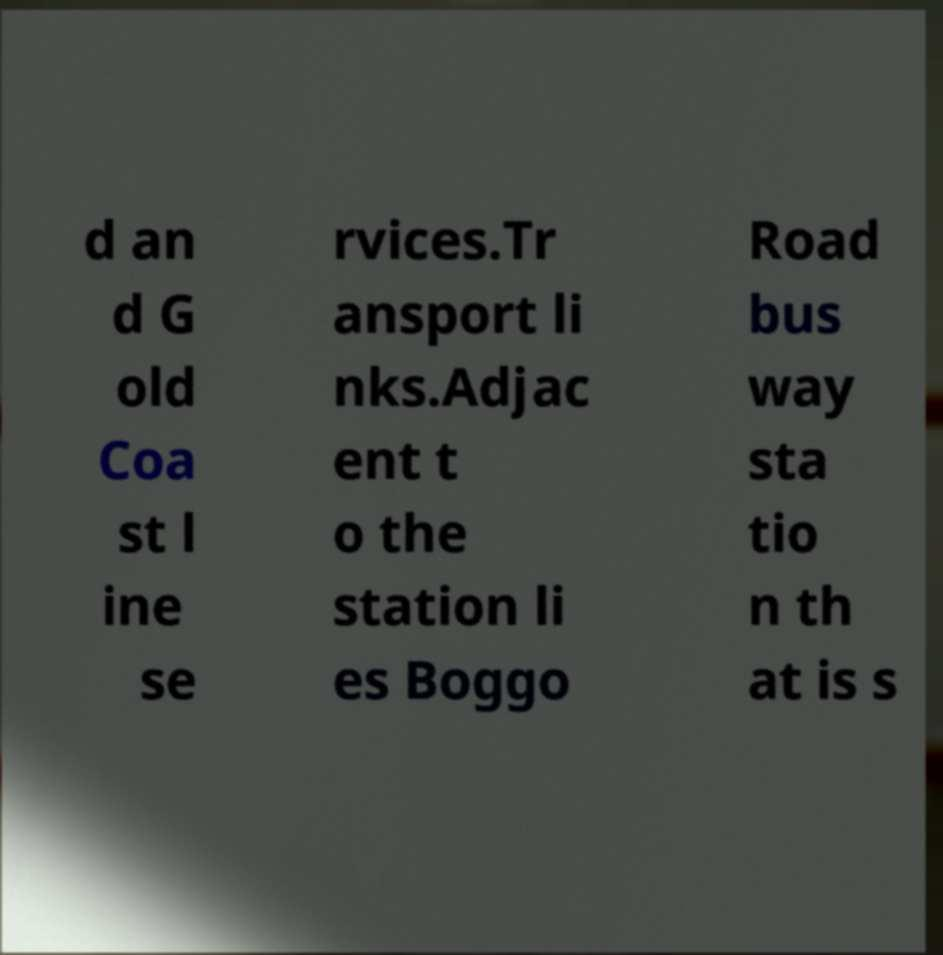Can you read and provide the text displayed in the image?This photo seems to have some interesting text. Can you extract and type it out for me? d an d G old Coa st l ine se rvices.Tr ansport li nks.Adjac ent t o the station li es Boggo Road bus way sta tio n th at is s 